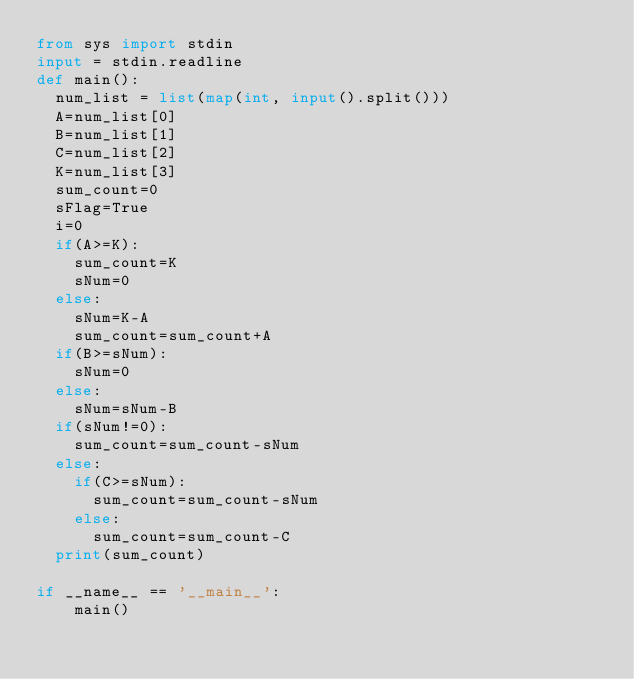<code> <loc_0><loc_0><loc_500><loc_500><_Python_>from sys import stdin
input = stdin.readline
def main():
  num_list = list(map(int, input().split()))
  A=num_list[0]
  B=num_list[1]
  C=num_list[2]
  K=num_list[3]
  sum_count=0
  sFlag=True
  i=0
  if(A>=K):
    sum_count=K
    sNum=0
  else:
    sNum=K-A
    sum_count=sum_count+A
  if(B>=sNum):
    sNum=0
  else:
    sNum=sNum-B
  if(sNum!=0):
    sum_count=sum_count-sNum
  else:
    if(C>=sNum):
      sum_count=sum_count-sNum
    else:
      sum_count=sum_count-C
  print(sum_count)

if __name__ == '__main__':
    main()</code> 